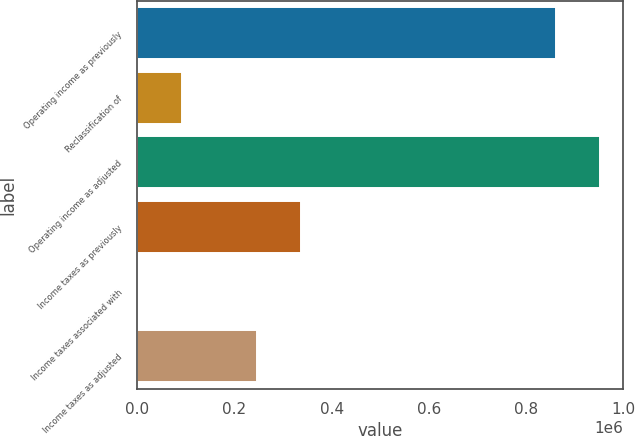Convert chart. <chart><loc_0><loc_0><loc_500><loc_500><bar_chart><fcel>Operating income as previously<fcel>Reclassification of<fcel>Operating income as adjusted<fcel>Income taxes as previously<fcel>Income taxes associated with<fcel>Income taxes as adjusted<nl><fcel>862209<fcel>91037.8<fcel>953084<fcel>336456<fcel>163<fcel>245581<nl></chart> 